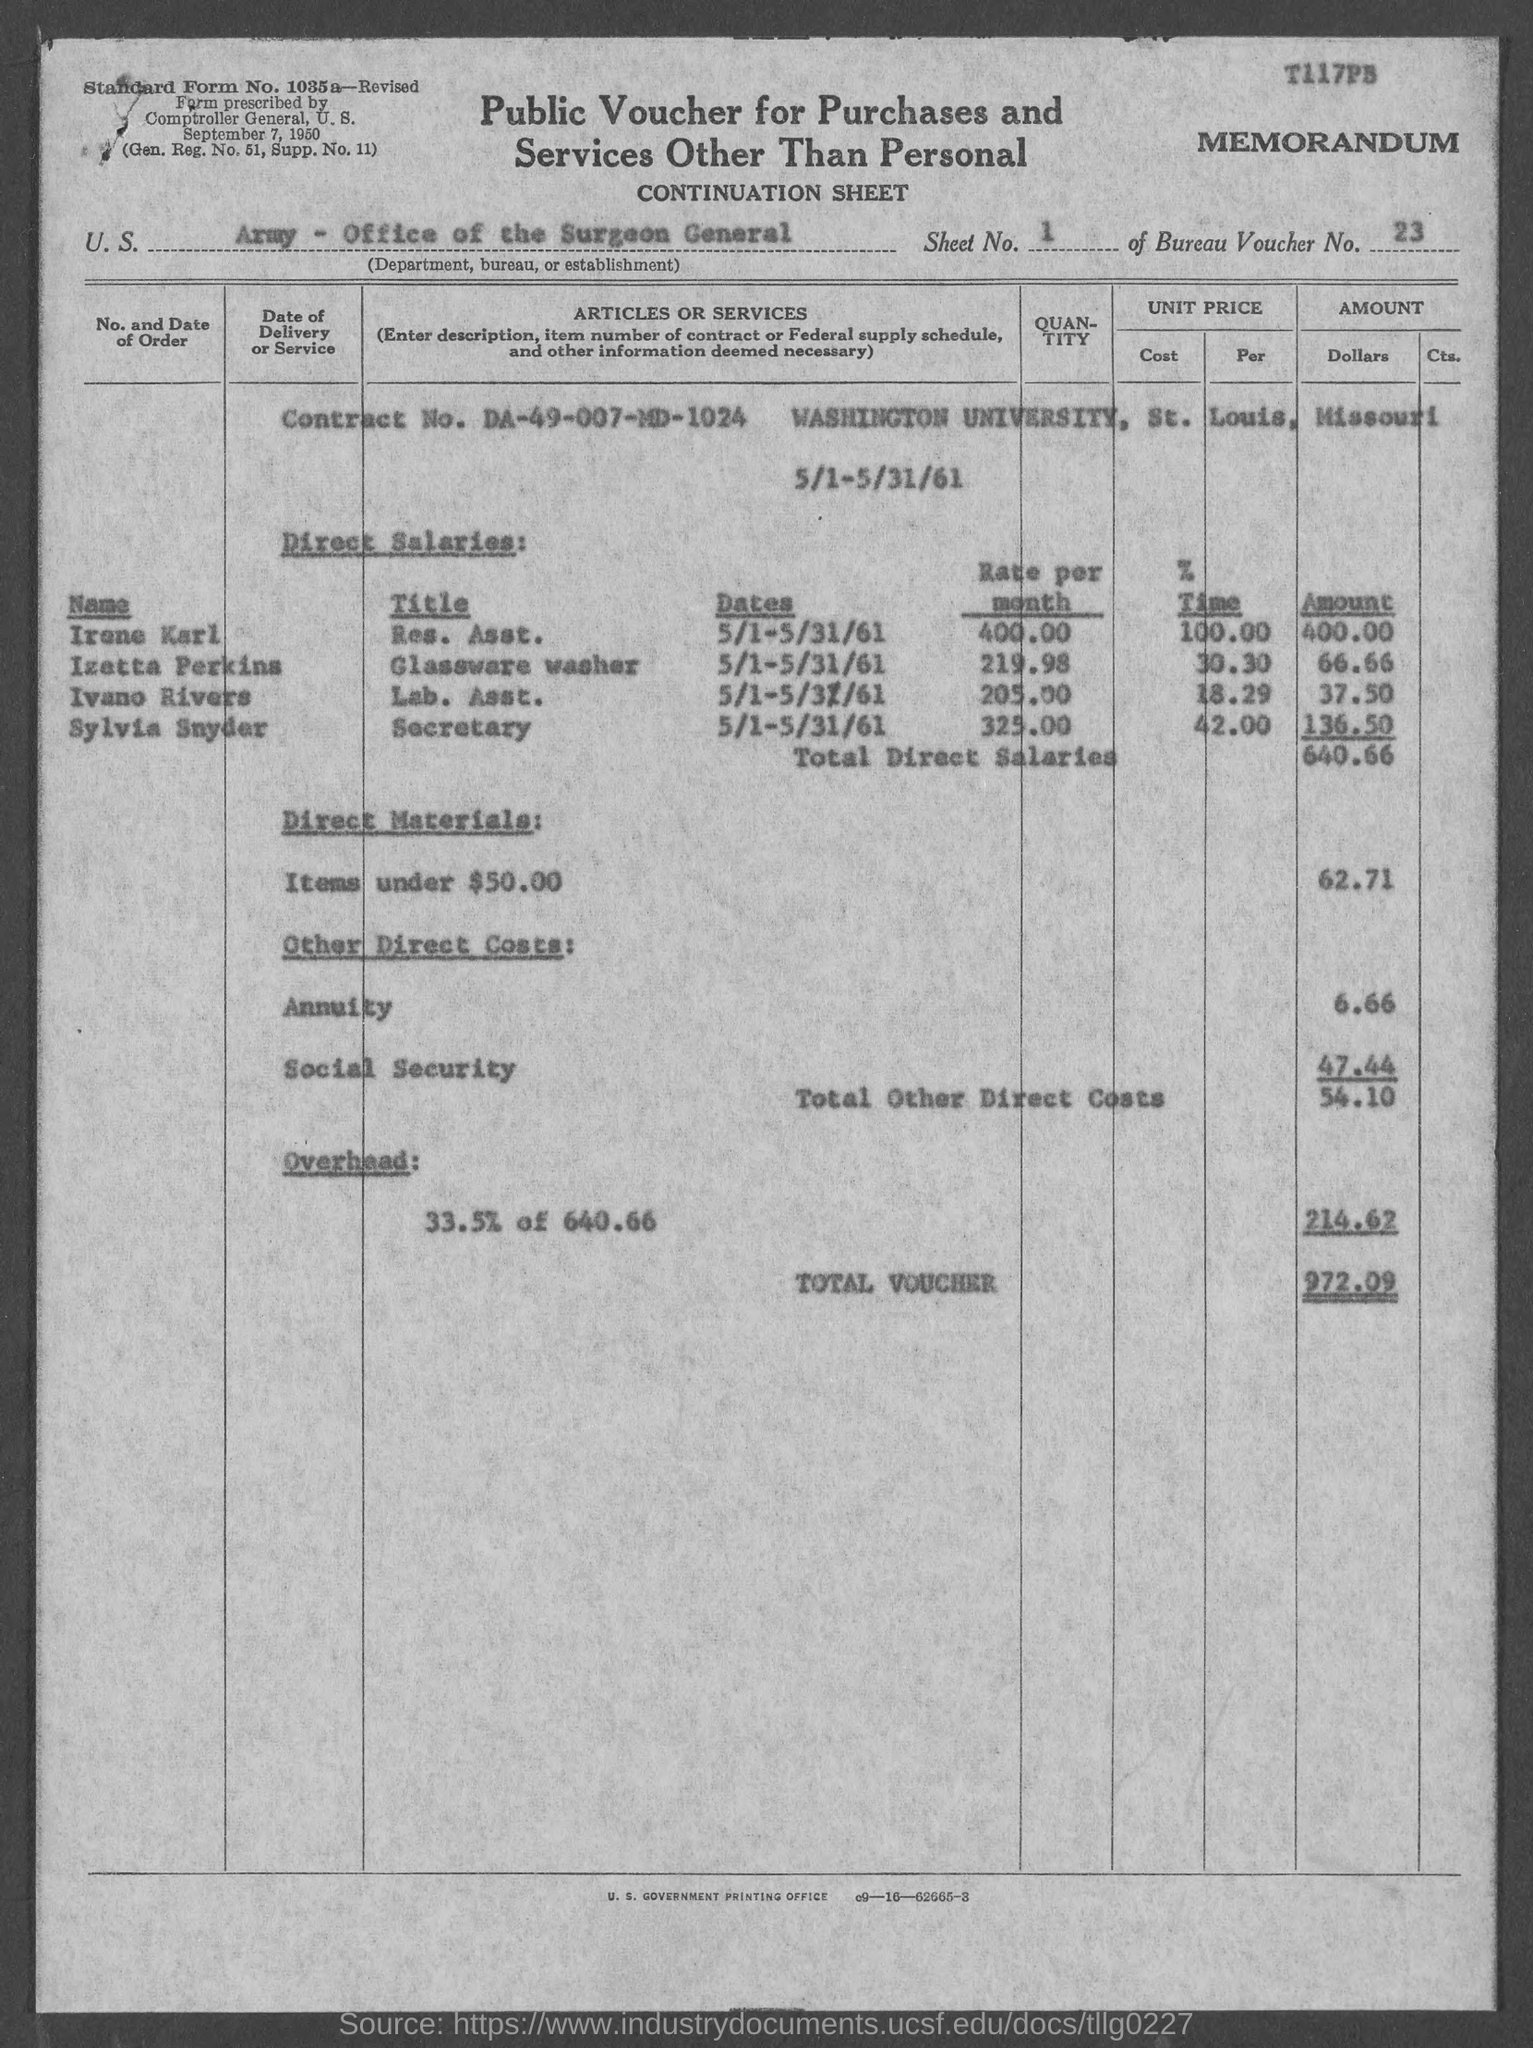Give some essential details in this illustration. Washington University is located in St. Louis, Missouri. The title of the form is "Public Voucher for Purchases and Services Other Than Personal," which is located at the top center of the document. The amount given for total direct salaries is 640.66. The Bureau Voucher Number is 23. Washington University is mentioned in this document. 